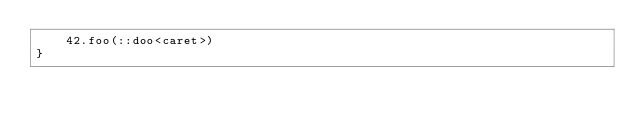<code> <loc_0><loc_0><loc_500><loc_500><_Kotlin_>    42.foo(::doo<caret>)
}</code> 